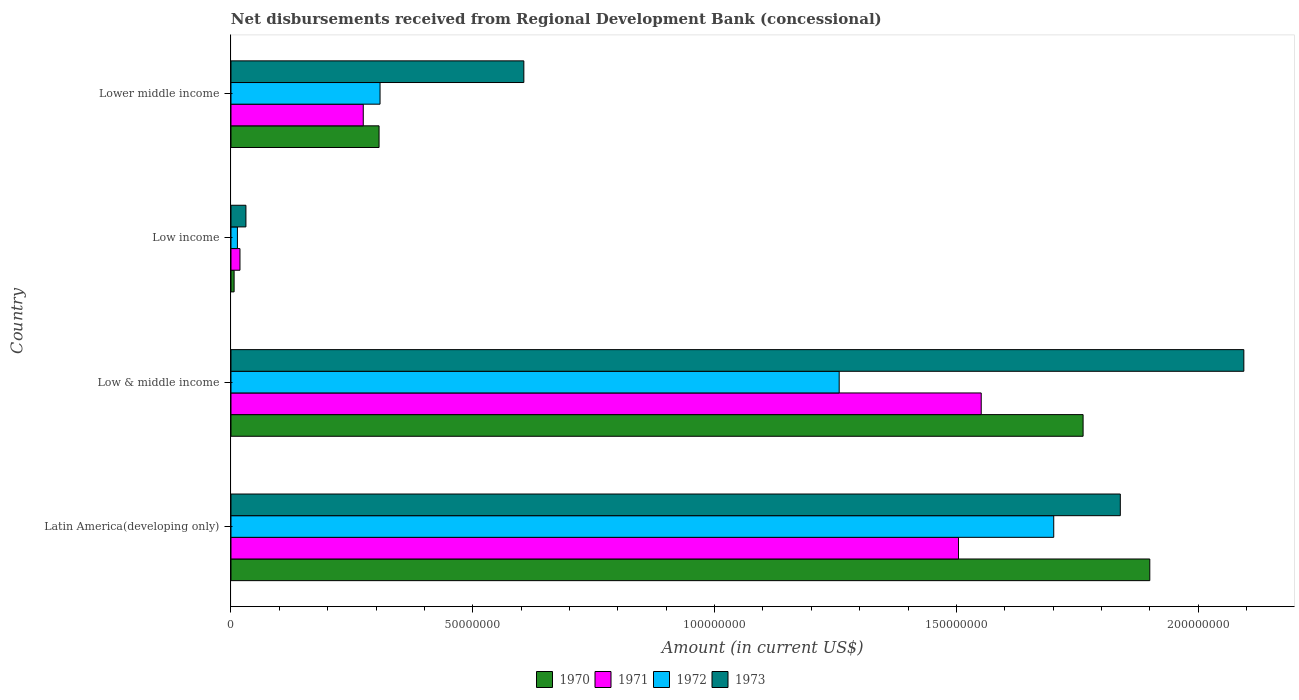How many different coloured bars are there?
Give a very brief answer. 4. How many groups of bars are there?
Give a very brief answer. 4. Are the number of bars on each tick of the Y-axis equal?
Your response must be concise. Yes. What is the label of the 1st group of bars from the top?
Your answer should be very brief. Lower middle income. In how many cases, is the number of bars for a given country not equal to the number of legend labels?
Provide a short and direct response. 0. What is the amount of disbursements received from Regional Development Bank in 1971 in Low & middle income?
Give a very brief answer. 1.55e+08. Across all countries, what is the maximum amount of disbursements received from Regional Development Bank in 1973?
Provide a succinct answer. 2.09e+08. Across all countries, what is the minimum amount of disbursements received from Regional Development Bank in 1970?
Give a very brief answer. 6.47e+05. In which country was the amount of disbursements received from Regional Development Bank in 1970 maximum?
Give a very brief answer. Latin America(developing only). In which country was the amount of disbursements received from Regional Development Bank in 1972 minimum?
Offer a very short reply. Low income. What is the total amount of disbursements received from Regional Development Bank in 1973 in the graph?
Provide a short and direct response. 4.57e+08. What is the difference between the amount of disbursements received from Regional Development Bank in 1972 in Low income and that in Lower middle income?
Offer a very short reply. -2.95e+07. What is the difference between the amount of disbursements received from Regional Development Bank in 1970 in Latin America(developing only) and the amount of disbursements received from Regional Development Bank in 1973 in Lower middle income?
Offer a terse response. 1.29e+08. What is the average amount of disbursements received from Regional Development Bank in 1970 per country?
Give a very brief answer. 9.94e+07. What is the difference between the amount of disbursements received from Regional Development Bank in 1973 and amount of disbursements received from Regional Development Bank in 1972 in Low income?
Offer a very short reply. 1.76e+06. What is the ratio of the amount of disbursements received from Regional Development Bank in 1971 in Low & middle income to that in Lower middle income?
Provide a short and direct response. 5.67. Is the amount of disbursements received from Regional Development Bank in 1970 in Low & middle income less than that in Lower middle income?
Provide a succinct answer. No. Is the difference between the amount of disbursements received from Regional Development Bank in 1973 in Latin America(developing only) and Lower middle income greater than the difference between the amount of disbursements received from Regional Development Bank in 1972 in Latin America(developing only) and Lower middle income?
Provide a succinct answer. No. What is the difference between the highest and the second highest amount of disbursements received from Regional Development Bank in 1973?
Give a very brief answer. 2.55e+07. What is the difference between the highest and the lowest amount of disbursements received from Regional Development Bank in 1973?
Make the answer very short. 2.06e+08. Is it the case that in every country, the sum of the amount of disbursements received from Regional Development Bank in 1972 and amount of disbursements received from Regional Development Bank in 1973 is greater than the sum of amount of disbursements received from Regional Development Bank in 1971 and amount of disbursements received from Regional Development Bank in 1970?
Keep it short and to the point. No. What does the 3rd bar from the bottom in Lower middle income represents?
Make the answer very short. 1972. Are all the bars in the graph horizontal?
Your response must be concise. Yes. Are the values on the major ticks of X-axis written in scientific E-notation?
Keep it short and to the point. No. Does the graph contain any zero values?
Give a very brief answer. No. Does the graph contain grids?
Provide a succinct answer. No. Where does the legend appear in the graph?
Make the answer very short. Bottom center. How many legend labels are there?
Offer a very short reply. 4. How are the legend labels stacked?
Keep it short and to the point. Horizontal. What is the title of the graph?
Your answer should be compact. Net disbursements received from Regional Development Bank (concessional). Does "1974" appear as one of the legend labels in the graph?
Your answer should be compact. No. What is the label or title of the X-axis?
Your answer should be very brief. Amount (in current US$). What is the label or title of the Y-axis?
Ensure brevity in your answer.  Country. What is the Amount (in current US$) of 1970 in Latin America(developing only)?
Your answer should be compact. 1.90e+08. What is the Amount (in current US$) in 1971 in Latin America(developing only)?
Your answer should be very brief. 1.50e+08. What is the Amount (in current US$) of 1972 in Latin America(developing only)?
Offer a terse response. 1.70e+08. What is the Amount (in current US$) of 1973 in Latin America(developing only)?
Ensure brevity in your answer.  1.84e+08. What is the Amount (in current US$) in 1970 in Low & middle income?
Provide a short and direct response. 1.76e+08. What is the Amount (in current US$) in 1971 in Low & middle income?
Provide a succinct answer. 1.55e+08. What is the Amount (in current US$) in 1972 in Low & middle income?
Your answer should be compact. 1.26e+08. What is the Amount (in current US$) of 1973 in Low & middle income?
Offer a very short reply. 2.09e+08. What is the Amount (in current US$) of 1970 in Low income?
Offer a very short reply. 6.47e+05. What is the Amount (in current US$) in 1971 in Low income?
Give a very brief answer. 1.86e+06. What is the Amount (in current US$) of 1972 in Low income?
Provide a succinct answer. 1.33e+06. What is the Amount (in current US$) of 1973 in Low income?
Your answer should be very brief. 3.09e+06. What is the Amount (in current US$) in 1970 in Lower middle income?
Your response must be concise. 3.06e+07. What is the Amount (in current US$) in 1971 in Lower middle income?
Provide a short and direct response. 2.74e+07. What is the Amount (in current US$) in 1972 in Lower middle income?
Your response must be concise. 3.08e+07. What is the Amount (in current US$) in 1973 in Lower middle income?
Offer a terse response. 6.06e+07. Across all countries, what is the maximum Amount (in current US$) of 1970?
Provide a succinct answer. 1.90e+08. Across all countries, what is the maximum Amount (in current US$) in 1971?
Ensure brevity in your answer.  1.55e+08. Across all countries, what is the maximum Amount (in current US$) of 1972?
Your answer should be very brief. 1.70e+08. Across all countries, what is the maximum Amount (in current US$) of 1973?
Give a very brief answer. 2.09e+08. Across all countries, what is the minimum Amount (in current US$) of 1970?
Offer a terse response. 6.47e+05. Across all countries, what is the minimum Amount (in current US$) of 1971?
Offer a very short reply. 1.86e+06. Across all countries, what is the minimum Amount (in current US$) in 1972?
Keep it short and to the point. 1.33e+06. Across all countries, what is the minimum Amount (in current US$) of 1973?
Your response must be concise. 3.09e+06. What is the total Amount (in current US$) in 1970 in the graph?
Your answer should be compact. 3.97e+08. What is the total Amount (in current US$) in 1971 in the graph?
Your answer should be very brief. 3.35e+08. What is the total Amount (in current US$) of 1972 in the graph?
Provide a short and direct response. 3.28e+08. What is the total Amount (in current US$) in 1973 in the graph?
Offer a very short reply. 4.57e+08. What is the difference between the Amount (in current US$) of 1970 in Latin America(developing only) and that in Low & middle income?
Your answer should be compact. 1.38e+07. What is the difference between the Amount (in current US$) in 1971 in Latin America(developing only) and that in Low & middle income?
Make the answer very short. -4.69e+06. What is the difference between the Amount (in current US$) in 1972 in Latin America(developing only) and that in Low & middle income?
Your answer should be compact. 4.44e+07. What is the difference between the Amount (in current US$) in 1973 in Latin America(developing only) and that in Low & middle income?
Your response must be concise. -2.55e+07. What is the difference between the Amount (in current US$) of 1970 in Latin America(developing only) and that in Low income?
Your answer should be very brief. 1.89e+08. What is the difference between the Amount (in current US$) in 1971 in Latin America(developing only) and that in Low income?
Your answer should be compact. 1.49e+08. What is the difference between the Amount (in current US$) in 1972 in Latin America(developing only) and that in Low income?
Your answer should be compact. 1.69e+08. What is the difference between the Amount (in current US$) in 1973 in Latin America(developing only) and that in Low income?
Ensure brevity in your answer.  1.81e+08. What is the difference between the Amount (in current US$) of 1970 in Latin America(developing only) and that in Lower middle income?
Your answer should be very brief. 1.59e+08. What is the difference between the Amount (in current US$) of 1971 in Latin America(developing only) and that in Lower middle income?
Provide a succinct answer. 1.23e+08. What is the difference between the Amount (in current US$) of 1972 in Latin America(developing only) and that in Lower middle income?
Provide a short and direct response. 1.39e+08. What is the difference between the Amount (in current US$) in 1973 in Latin America(developing only) and that in Lower middle income?
Give a very brief answer. 1.23e+08. What is the difference between the Amount (in current US$) in 1970 in Low & middle income and that in Low income?
Your answer should be very brief. 1.76e+08. What is the difference between the Amount (in current US$) of 1971 in Low & middle income and that in Low income?
Give a very brief answer. 1.53e+08. What is the difference between the Amount (in current US$) in 1972 in Low & middle income and that in Low income?
Offer a terse response. 1.24e+08. What is the difference between the Amount (in current US$) of 1973 in Low & middle income and that in Low income?
Keep it short and to the point. 2.06e+08. What is the difference between the Amount (in current US$) of 1970 in Low & middle income and that in Lower middle income?
Offer a terse response. 1.46e+08. What is the difference between the Amount (in current US$) of 1971 in Low & middle income and that in Lower middle income?
Offer a terse response. 1.28e+08. What is the difference between the Amount (in current US$) of 1972 in Low & middle income and that in Lower middle income?
Your answer should be compact. 9.49e+07. What is the difference between the Amount (in current US$) in 1973 in Low & middle income and that in Lower middle income?
Provide a short and direct response. 1.49e+08. What is the difference between the Amount (in current US$) of 1970 in Low income and that in Lower middle income?
Your answer should be very brief. -3.00e+07. What is the difference between the Amount (in current US$) of 1971 in Low income and that in Lower middle income?
Provide a short and direct response. -2.55e+07. What is the difference between the Amount (in current US$) in 1972 in Low income and that in Lower middle income?
Keep it short and to the point. -2.95e+07. What is the difference between the Amount (in current US$) of 1973 in Low income and that in Lower middle income?
Your response must be concise. -5.75e+07. What is the difference between the Amount (in current US$) in 1970 in Latin America(developing only) and the Amount (in current US$) in 1971 in Low & middle income?
Provide a succinct answer. 3.49e+07. What is the difference between the Amount (in current US$) of 1970 in Latin America(developing only) and the Amount (in current US$) of 1972 in Low & middle income?
Your answer should be compact. 6.42e+07. What is the difference between the Amount (in current US$) in 1970 in Latin America(developing only) and the Amount (in current US$) in 1973 in Low & middle income?
Keep it short and to the point. -1.94e+07. What is the difference between the Amount (in current US$) in 1971 in Latin America(developing only) and the Amount (in current US$) in 1972 in Low & middle income?
Ensure brevity in your answer.  2.47e+07. What is the difference between the Amount (in current US$) in 1971 in Latin America(developing only) and the Amount (in current US$) in 1973 in Low & middle income?
Your answer should be very brief. -5.90e+07. What is the difference between the Amount (in current US$) in 1972 in Latin America(developing only) and the Amount (in current US$) in 1973 in Low & middle income?
Offer a terse response. -3.93e+07. What is the difference between the Amount (in current US$) in 1970 in Latin America(developing only) and the Amount (in current US$) in 1971 in Low income?
Offer a very short reply. 1.88e+08. What is the difference between the Amount (in current US$) in 1970 in Latin America(developing only) and the Amount (in current US$) in 1972 in Low income?
Your answer should be very brief. 1.89e+08. What is the difference between the Amount (in current US$) of 1970 in Latin America(developing only) and the Amount (in current US$) of 1973 in Low income?
Keep it short and to the point. 1.87e+08. What is the difference between the Amount (in current US$) in 1971 in Latin America(developing only) and the Amount (in current US$) in 1972 in Low income?
Give a very brief answer. 1.49e+08. What is the difference between the Amount (in current US$) in 1971 in Latin America(developing only) and the Amount (in current US$) in 1973 in Low income?
Keep it short and to the point. 1.47e+08. What is the difference between the Amount (in current US$) of 1972 in Latin America(developing only) and the Amount (in current US$) of 1973 in Low income?
Ensure brevity in your answer.  1.67e+08. What is the difference between the Amount (in current US$) in 1970 in Latin America(developing only) and the Amount (in current US$) in 1971 in Lower middle income?
Provide a short and direct response. 1.63e+08. What is the difference between the Amount (in current US$) in 1970 in Latin America(developing only) and the Amount (in current US$) in 1972 in Lower middle income?
Your answer should be very brief. 1.59e+08. What is the difference between the Amount (in current US$) in 1970 in Latin America(developing only) and the Amount (in current US$) in 1973 in Lower middle income?
Your answer should be compact. 1.29e+08. What is the difference between the Amount (in current US$) in 1971 in Latin America(developing only) and the Amount (in current US$) in 1972 in Lower middle income?
Offer a very short reply. 1.20e+08. What is the difference between the Amount (in current US$) in 1971 in Latin America(developing only) and the Amount (in current US$) in 1973 in Lower middle income?
Your answer should be compact. 8.99e+07. What is the difference between the Amount (in current US$) of 1972 in Latin America(developing only) and the Amount (in current US$) of 1973 in Lower middle income?
Offer a very short reply. 1.10e+08. What is the difference between the Amount (in current US$) in 1970 in Low & middle income and the Amount (in current US$) in 1971 in Low income?
Your response must be concise. 1.74e+08. What is the difference between the Amount (in current US$) in 1970 in Low & middle income and the Amount (in current US$) in 1972 in Low income?
Offer a very short reply. 1.75e+08. What is the difference between the Amount (in current US$) in 1970 in Low & middle income and the Amount (in current US$) in 1973 in Low income?
Make the answer very short. 1.73e+08. What is the difference between the Amount (in current US$) in 1971 in Low & middle income and the Amount (in current US$) in 1972 in Low income?
Offer a terse response. 1.54e+08. What is the difference between the Amount (in current US$) of 1971 in Low & middle income and the Amount (in current US$) of 1973 in Low income?
Provide a short and direct response. 1.52e+08. What is the difference between the Amount (in current US$) of 1972 in Low & middle income and the Amount (in current US$) of 1973 in Low income?
Offer a terse response. 1.23e+08. What is the difference between the Amount (in current US$) of 1970 in Low & middle income and the Amount (in current US$) of 1971 in Lower middle income?
Provide a succinct answer. 1.49e+08. What is the difference between the Amount (in current US$) of 1970 in Low & middle income and the Amount (in current US$) of 1972 in Lower middle income?
Make the answer very short. 1.45e+08. What is the difference between the Amount (in current US$) of 1970 in Low & middle income and the Amount (in current US$) of 1973 in Lower middle income?
Ensure brevity in your answer.  1.16e+08. What is the difference between the Amount (in current US$) of 1971 in Low & middle income and the Amount (in current US$) of 1972 in Lower middle income?
Your answer should be very brief. 1.24e+08. What is the difference between the Amount (in current US$) in 1971 in Low & middle income and the Amount (in current US$) in 1973 in Lower middle income?
Offer a very short reply. 9.46e+07. What is the difference between the Amount (in current US$) of 1972 in Low & middle income and the Amount (in current US$) of 1973 in Lower middle income?
Offer a terse response. 6.52e+07. What is the difference between the Amount (in current US$) in 1970 in Low income and the Amount (in current US$) in 1971 in Lower middle income?
Give a very brief answer. -2.67e+07. What is the difference between the Amount (in current US$) in 1970 in Low income and the Amount (in current US$) in 1972 in Lower middle income?
Offer a very short reply. -3.02e+07. What is the difference between the Amount (in current US$) in 1970 in Low income and the Amount (in current US$) in 1973 in Lower middle income?
Provide a short and direct response. -5.99e+07. What is the difference between the Amount (in current US$) of 1971 in Low income and the Amount (in current US$) of 1972 in Lower middle income?
Make the answer very short. -2.90e+07. What is the difference between the Amount (in current US$) of 1971 in Low income and the Amount (in current US$) of 1973 in Lower middle income?
Your answer should be compact. -5.87e+07. What is the difference between the Amount (in current US$) of 1972 in Low income and the Amount (in current US$) of 1973 in Lower middle income?
Offer a terse response. -5.92e+07. What is the average Amount (in current US$) in 1970 per country?
Offer a terse response. 9.94e+07. What is the average Amount (in current US$) in 1971 per country?
Provide a short and direct response. 8.37e+07. What is the average Amount (in current US$) in 1972 per country?
Provide a succinct answer. 8.20e+07. What is the average Amount (in current US$) in 1973 per country?
Offer a terse response. 1.14e+08. What is the difference between the Amount (in current US$) of 1970 and Amount (in current US$) of 1971 in Latin America(developing only)?
Give a very brief answer. 3.96e+07. What is the difference between the Amount (in current US$) in 1970 and Amount (in current US$) in 1972 in Latin America(developing only)?
Ensure brevity in your answer.  1.99e+07. What is the difference between the Amount (in current US$) in 1970 and Amount (in current US$) in 1973 in Latin America(developing only)?
Give a very brief answer. 6.10e+06. What is the difference between the Amount (in current US$) of 1971 and Amount (in current US$) of 1972 in Latin America(developing only)?
Provide a short and direct response. -1.97e+07. What is the difference between the Amount (in current US$) in 1971 and Amount (in current US$) in 1973 in Latin America(developing only)?
Your answer should be very brief. -3.35e+07. What is the difference between the Amount (in current US$) in 1972 and Amount (in current US$) in 1973 in Latin America(developing only)?
Provide a succinct answer. -1.38e+07. What is the difference between the Amount (in current US$) in 1970 and Amount (in current US$) in 1971 in Low & middle income?
Offer a very short reply. 2.11e+07. What is the difference between the Amount (in current US$) in 1970 and Amount (in current US$) in 1972 in Low & middle income?
Provide a succinct answer. 5.04e+07. What is the difference between the Amount (in current US$) of 1970 and Amount (in current US$) of 1973 in Low & middle income?
Offer a very short reply. -3.32e+07. What is the difference between the Amount (in current US$) in 1971 and Amount (in current US$) in 1972 in Low & middle income?
Provide a succinct answer. 2.94e+07. What is the difference between the Amount (in current US$) of 1971 and Amount (in current US$) of 1973 in Low & middle income?
Your response must be concise. -5.43e+07. What is the difference between the Amount (in current US$) of 1972 and Amount (in current US$) of 1973 in Low & middle income?
Keep it short and to the point. -8.37e+07. What is the difference between the Amount (in current US$) of 1970 and Amount (in current US$) of 1971 in Low income?
Keep it short and to the point. -1.21e+06. What is the difference between the Amount (in current US$) in 1970 and Amount (in current US$) in 1972 in Low income?
Keep it short and to the point. -6.86e+05. What is the difference between the Amount (in current US$) of 1970 and Amount (in current US$) of 1973 in Low income?
Keep it short and to the point. -2.44e+06. What is the difference between the Amount (in current US$) of 1971 and Amount (in current US$) of 1972 in Low income?
Make the answer very short. 5.26e+05. What is the difference between the Amount (in current US$) in 1971 and Amount (in current US$) in 1973 in Low income?
Provide a succinct answer. -1.23e+06. What is the difference between the Amount (in current US$) of 1972 and Amount (in current US$) of 1973 in Low income?
Your answer should be compact. -1.76e+06. What is the difference between the Amount (in current US$) in 1970 and Amount (in current US$) in 1971 in Lower middle income?
Provide a short and direct response. 3.27e+06. What is the difference between the Amount (in current US$) in 1970 and Amount (in current US$) in 1972 in Lower middle income?
Provide a succinct answer. -2.02e+05. What is the difference between the Amount (in current US$) in 1970 and Amount (in current US$) in 1973 in Lower middle income?
Ensure brevity in your answer.  -2.99e+07. What is the difference between the Amount (in current US$) in 1971 and Amount (in current US$) in 1972 in Lower middle income?
Provide a succinct answer. -3.47e+06. What is the difference between the Amount (in current US$) of 1971 and Amount (in current US$) of 1973 in Lower middle income?
Your answer should be very brief. -3.32e+07. What is the difference between the Amount (in current US$) of 1972 and Amount (in current US$) of 1973 in Lower middle income?
Your response must be concise. -2.97e+07. What is the ratio of the Amount (in current US$) in 1970 in Latin America(developing only) to that in Low & middle income?
Your response must be concise. 1.08. What is the ratio of the Amount (in current US$) in 1971 in Latin America(developing only) to that in Low & middle income?
Your answer should be very brief. 0.97. What is the ratio of the Amount (in current US$) in 1972 in Latin America(developing only) to that in Low & middle income?
Your answer should be compact. 1.35. What is the ratio of the Amount (in current US$) of 1973 in Latin America(developing only) to that in Low & middle income?
Give a very brief answer. 0.88. What is the ratio of the Amount (in current US$) of 1970 in Latin America(developing only) to that in Low income?
Give a very brief answer. 293.65. What is the ratio of the Amount (in current US$) in 1971 in Latin America(developing only) to that in Low income?
Offer a very short reply. 80.93. What is the ratio of the Amount (in current US$) in 1972 in Latin America(developing only) to that in Low income?
Your answer should be compact. 127.63. What is the ratio of the Amount (in current US$) in 1973 in Latin America(developing only) to that in Low income?
Offer a very short reply. 59.49. What is the ratio of the Amount (in current US$) in 1970 in Latin America(developing only) to that in Lower middle income?
Keep it short and to the point. 6.2. What is the ratio of the Amount (in current US$) in 1971 in Latin America(developing only) to that in Lower middle income?
Keep it short and to the point. 5.5. What is the ratio of the Amount (in current US$) in 1972 in Latin America(developing only) to that in Lower middle income?
Offer a terse response. 5.52. What is the ratio of the Amount (in current US$) of 1973 in Latin America(developing only) to that in Lower middle income?
Offer a very short reply. 3.04. What is the ratio of the Amount (in current US$) in 1970 in Low & middle income to that in Low income?
Your answer should be very brief. 272.33. What is the ratio of the Amount (in current US$) in 1971 in Low & middle income to that in Low income?
Your response must be concise. 83.45. What is the ratio of the Amount (in current US$) of 1972 in Low & middle income to that in Low income?
Your answer should be very brief. 94.35. What is the ratio of the Amount (in current US$) in 1973 in Low & middle income to that in Low income?
Your response must be concise. 67.76. What is the ratio of the Amount (in current US$) in 1970 in Low & middle income to that in Lower middle income?
Keep it short and to the point. 5.75. What is the ratio of the Amount (in current US$) in 1971 in Low & middle income to that in Lower middle income?
Your answer should be very brief. 5.67. What is the ratio of the Amount (in current US$) in 1972 in Low & middle income to that in Lower middle income?
Give a very brief answer. 4.08. What is the ratio of the Amount (in current US$) in 1973 in Low & middle income to that in Lower middle income?
Ensure brevity in your answer.  3.46. What is the ratio of the Amount (in current US$) in 1970 in Low income to that in Lower middle income?
Offer a terse response. 0.02. What is the ratio of the Amount (in current US$) in 1971 in Low income to that in Lower middle income?
Your answer should be very brief. 0.07. What is the ratio of the Amount (in current US$) in 1972 in Low income to that in Lower middle income?
Make the answer very short. 0.04. What is the ratio of the Amount (in current US$) of 1973 in Low income to that in Lower middle income?
Provide a short and direct response. 0.05. What is the difference between the highest and the second highest Amount (in current US$) of 1970?
Offer a very short reply. 1.38e+07. What is the difference between the highest and the second highest Amount (in current US$) of 1971?
Provide a short and direct response. 4.69e+06. What is the difference between the highest and the second highest Amount (in current US$) in 1972?
Offer a terse response. 4.44e+07. What is the difference between the highest and the second highest Amount (in current US$) in 1973?
Give a very brief answer. 2.55e+07. What is the difference between the highest and the lowest Amount (in current US$) of 1970?
Your answer should be very brief. 1.89e+08. What is the difference between the highest and the lowest Amount (in current US$) in 1971?
Your answer should be compact. 1.53e+08. What is the difference between the highest and the lowest Amount (in current US$) in 1972?
Give a very brief answer. 1.69e+08. What is the difference between the highest and the lowest Amount (in current US$) in 1973?
Your answer should be compact. 2.06e+08. 